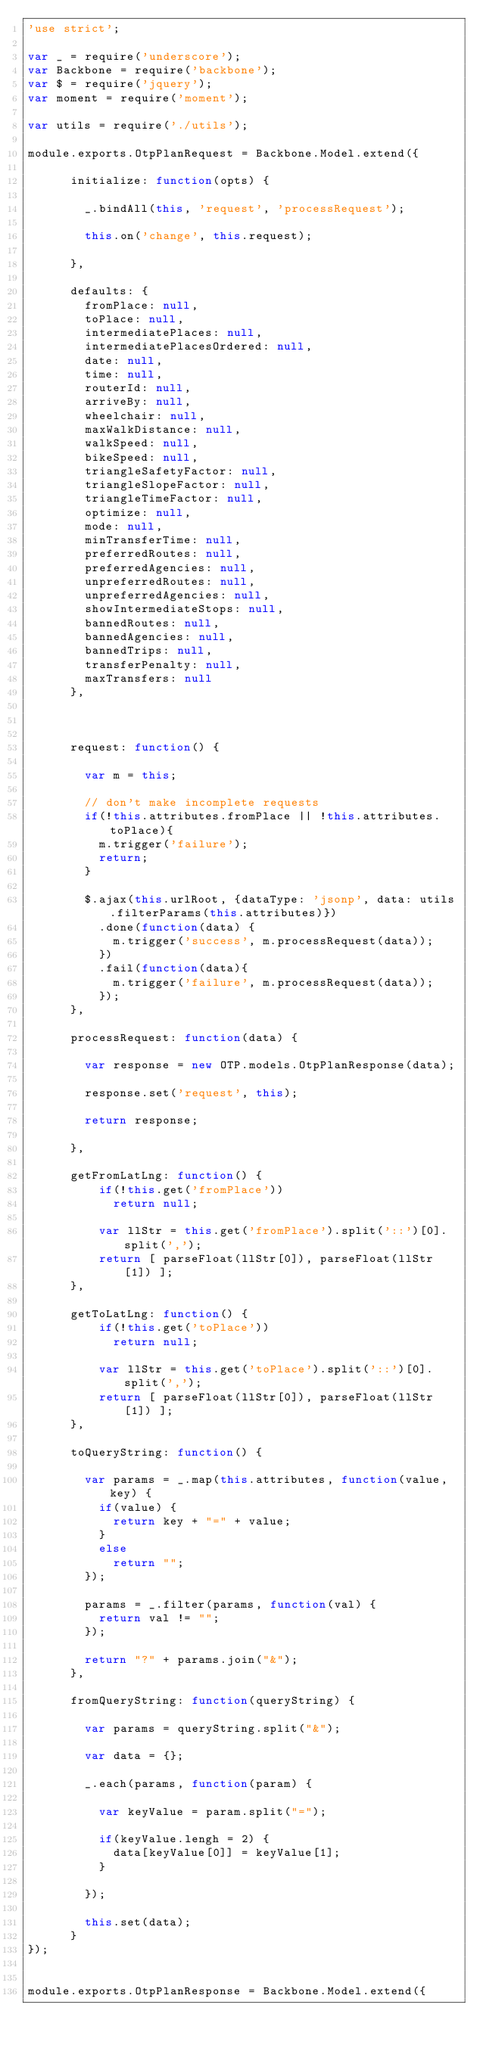Convert code to text. <code><loc_0><loc_0><loc_500><loc_500><_JavaScript_>'use strict';

var _ = require('underscore');
var Backbone = require('backbone');
var $ = require('jquery');
var moment = require('moment');

var utils = require('./utils');

module.exports.OtpPlanRequest = Backbone.Model.extend({ 

      initialize: function(opts) {

        _.bindAll(this, 'request', 'processRequest');

        this.on('change', this.request);

      },

      defaults: {  
        fromPlace: null,
        toPlace: null,
        intermediatePlaces: null,
        intermediatePlacesOrdered: null,
        date: null,
        time: null,
        routerId: null,
        arriveBy: null,
        wheelchair: null,
        maxWalkDistance: null,
        walkSpeed: null,  
        bikeSpeed: null,
        triangleSafetyFactor: null,
        triangleSlopeFactor: null,
        triangleTimeFactor: null,
        optimize: null,
        mode: null,
        minTransferTime: null,
        preferredRoutes: null,
        preferredAgencies: null,
        unpreferredRoutes: null,
        unpreferredAgencies: null,
        showIntermediateStops: null,
        bannedRoutes: null,
        bannedAgencies: null,
        bannedTrips: null,
        transferPenalty: null,
        maxTransfers: null
      },

      

      request: function() {

        var m = this;

        // don't make incomplete requests
        if(!this.attributes.fromPlace || !this.attributes.toPlace){
          m.trigger('failure');
          return;
        }
          
        $.ajax(this.urlRoot, {dataType: 'jsonp', data: utils.filterParams(this.attributes)})
          .done(function(data) {
            m.trigger('success', m.processRequest(data));
          })
          .fail(function(data){
            m.trigger('failure', m.processRequest(data));
          });
      },

      processRequest: function(data) {

        var response = new OTP.models.OtpPlanResponse(data);

        response.set('request', this);

        return response;

      },

      getFromLatLng: function() {
          if(!this.get('fromPlace'))
            return null;

          var llStr = this.get('fromPlace').split('::')[0].split(',');
          return [ parseFloat(llStr[0]), parseFloat(llStr[1]) ];
      },

      getToLatLng: function() {
          if(!this.get('toPlace'))
            return null;
          
          var llStr = this.get('toPlace').split('::')[0].split(',');
          return [ parseFloat(llStr[0]), parseFloat(llStr[1]) ];
      },

      toQueryString: function() {
        
        var params = _.map(this.attributes, function(value, key) {
          if(value) {
            return key + "=" + value;
          }
          else 
            return "";
        }); 

        params = _.filter(params, function(val) {
          return val != "";
        });

        return "?" + params.join("&");
      },

      fromQueryString: function(queryString) {

        var params = queryString.split("&");

        var data = {};

        _.each(params, function(param) {

          var keyValue = param.split("=");

          if(keyValue.lengh = 2) {
            data[keyValue[0]] = keyValue[1];            
          }

        });

        this.set(data);
      }
});


module.exports.OtpPlanResponse = Backbone.Model.extend({ 
</code> 